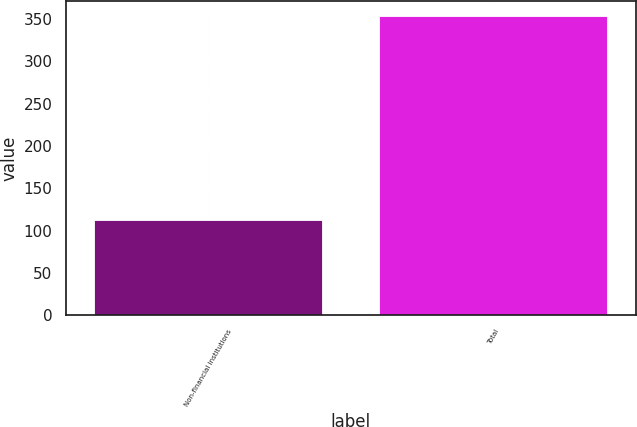Convert chart. <chart><loc_0><loc_0><loc_500><loc_500><bar_chart><fcel>Non-financial institutions<fcel>Total<nl><fcel>112.4<fcel>353.9<nl></chart> 